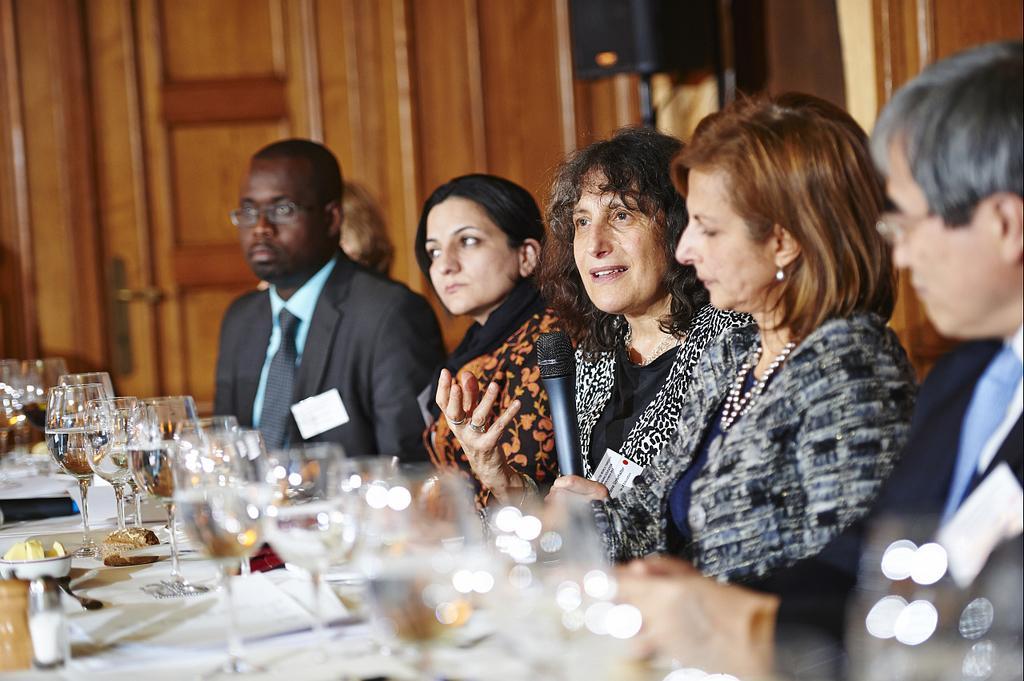Can you describe this image briefly? This image consists of five persons. In the middle, we can see a woman holding a mic. In the front, there is a table on which we can see the glasses and papers. In the background, there is a door made up of wood. 